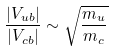Convert formula to latex. <formula><loc_0><loc_0><loc_500><loc_500>\frac { | V _ { u b } | } { | V _ { c b } | } \sim \sqrt { \frac { m _ { u } } { m _ { c } } }</formula> 